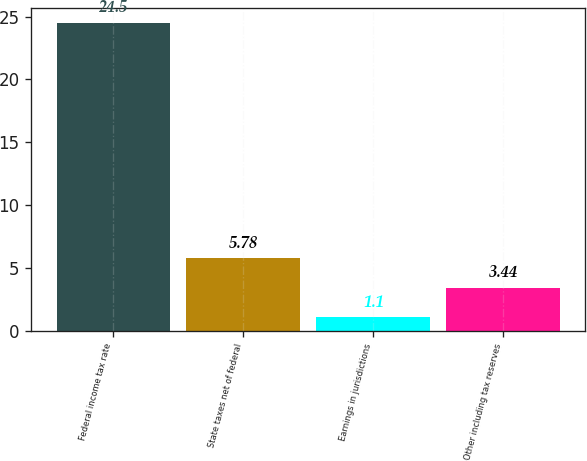Convert chart. <chart><loc_0><loc_0><loc_500><loc_500><bar_chart><fcel>Federal income tax rate<fcel>State taxes net of federal<fcel>Earnings in jurisdictions<fcel>Other including tax reserves<nl><fcel>24.5<fcel>5.78<fcel>1.1<fcel>3.44<nl></chart> 